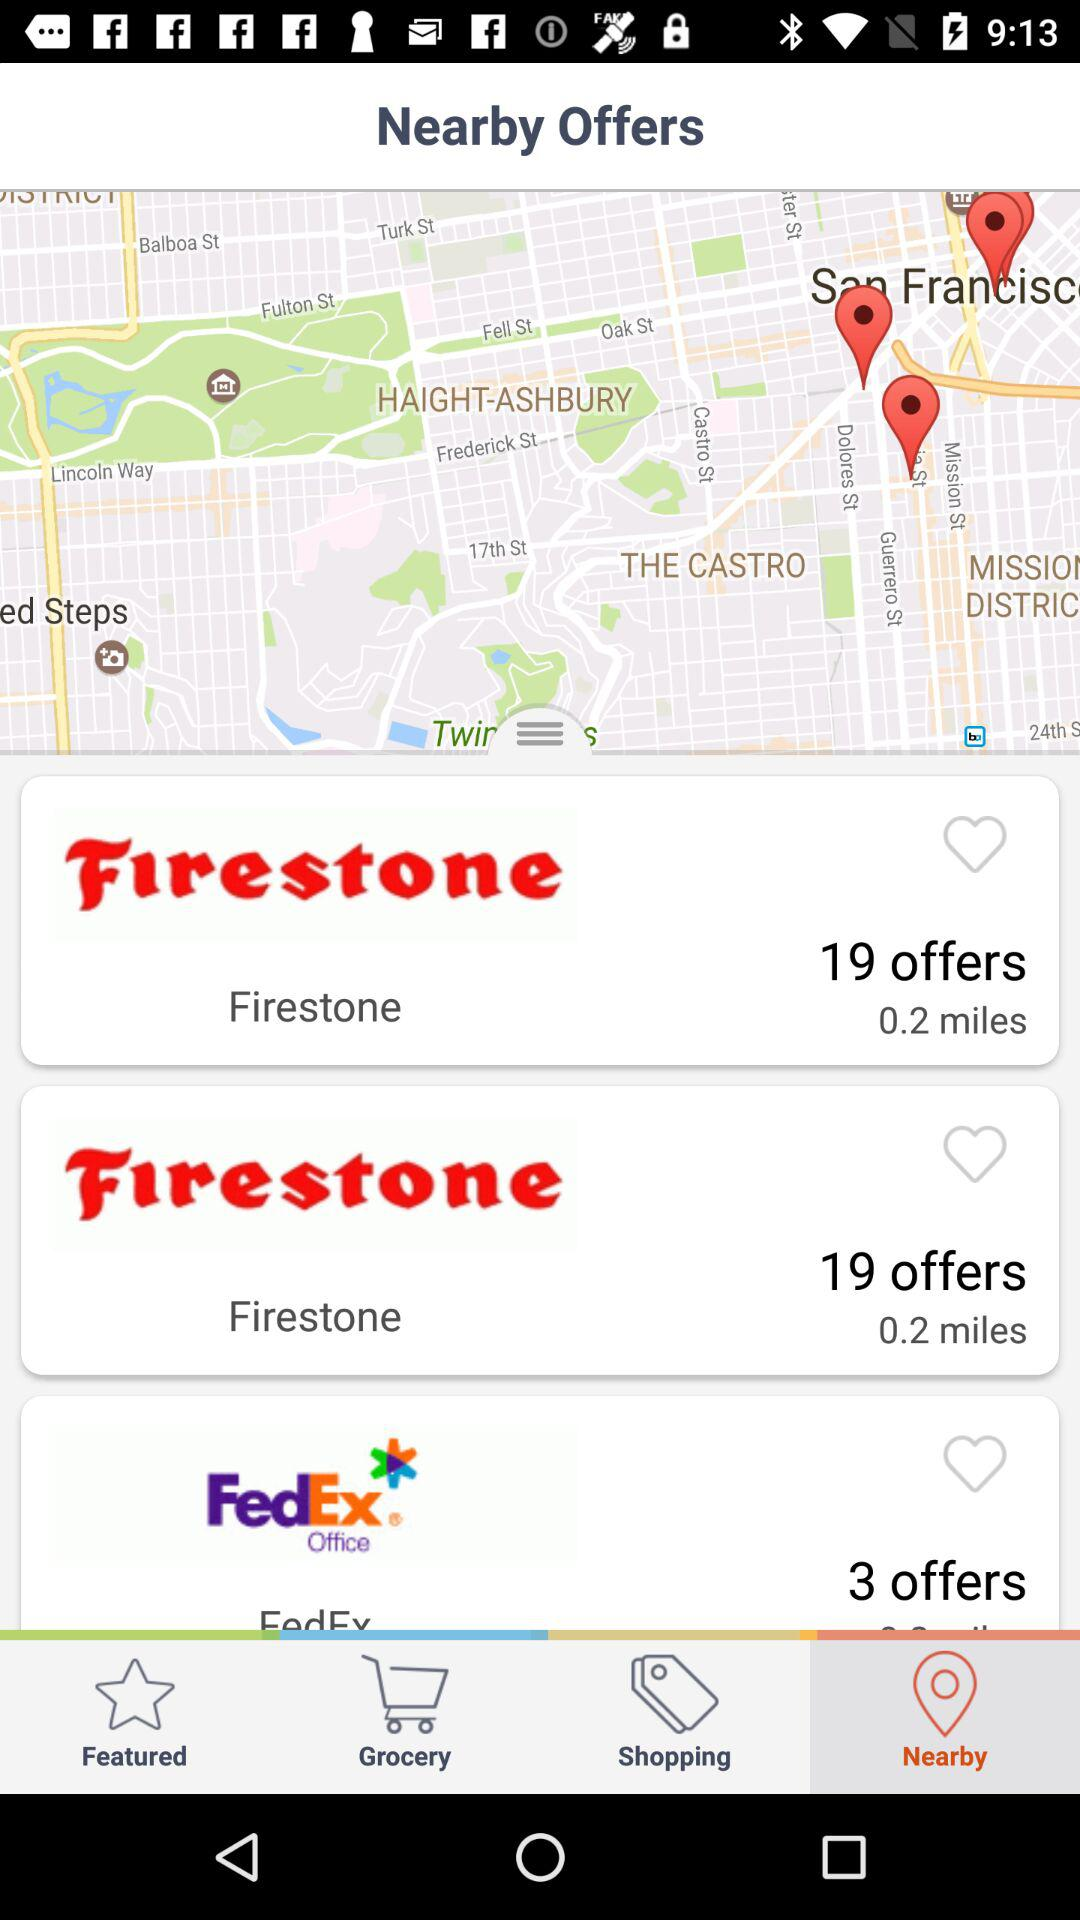How many offers are there for "Firestone"? There are 19 offers for "Firestone". 